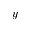Convert formula to latex. <formula><loc_0><loc_0><loc_500><loc_500>y</formula> 